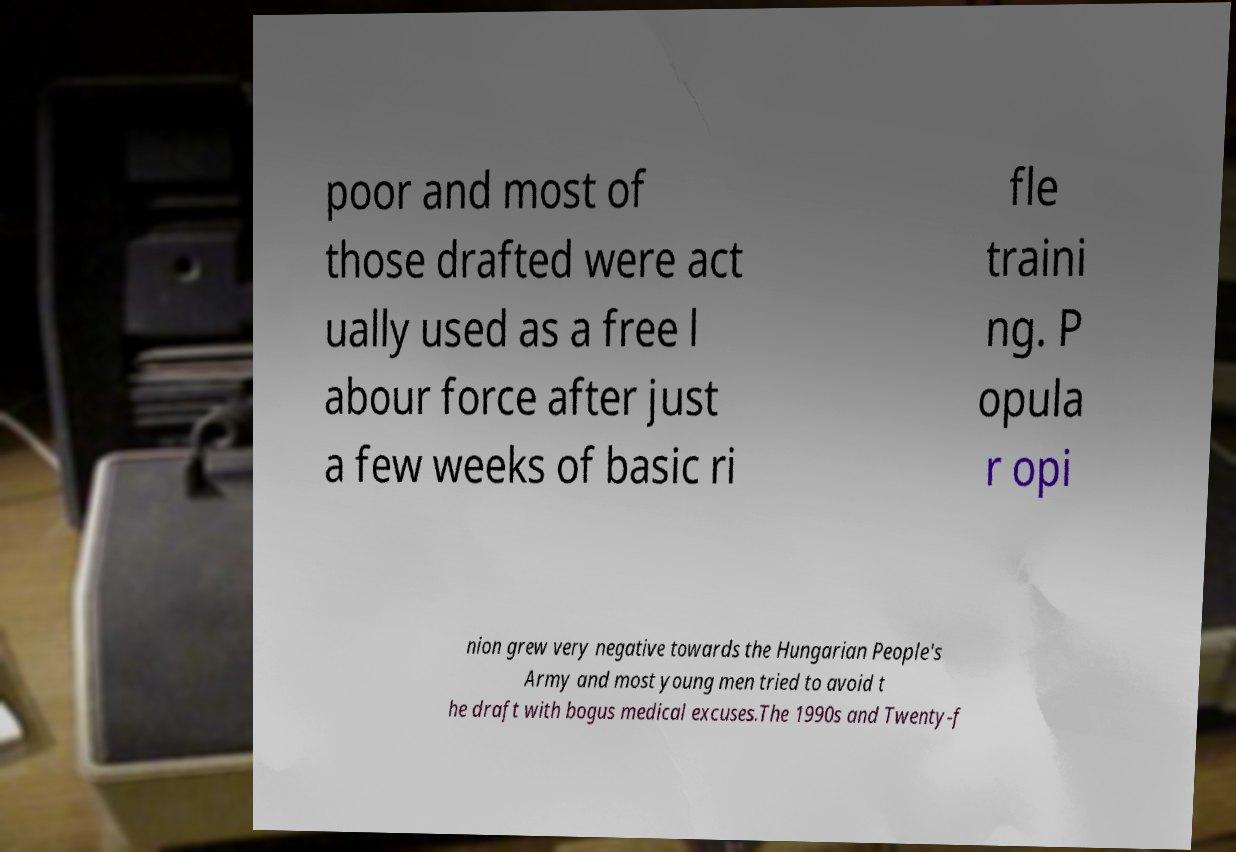Please identify and transcribe the text found in this image. poor and most of those drafted were act ually used as a free l abour force after just a few weeks of basic ri fle traini ng. P opula r opi nion grew very negative towards the Hungarian People's Army and most young men tried to avoid t he draft with bogus medical excuses.The 1990s and Twenty-f 